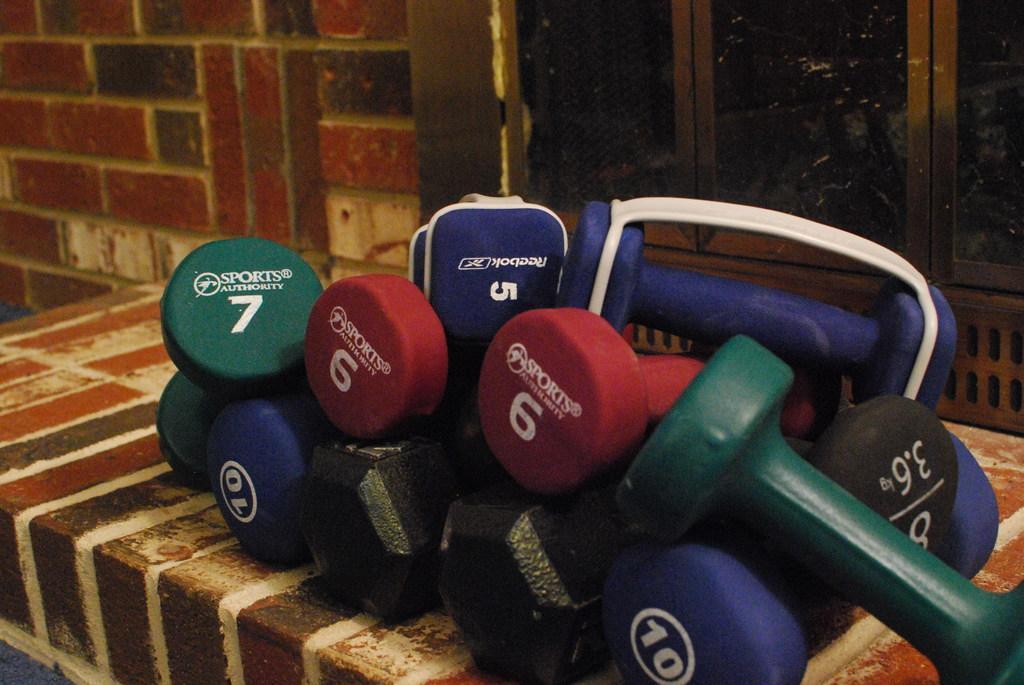Please provide a concise description of this image. In this picture there are colorful dumbbells in the center of the image and there are windows in the background area of the image. 